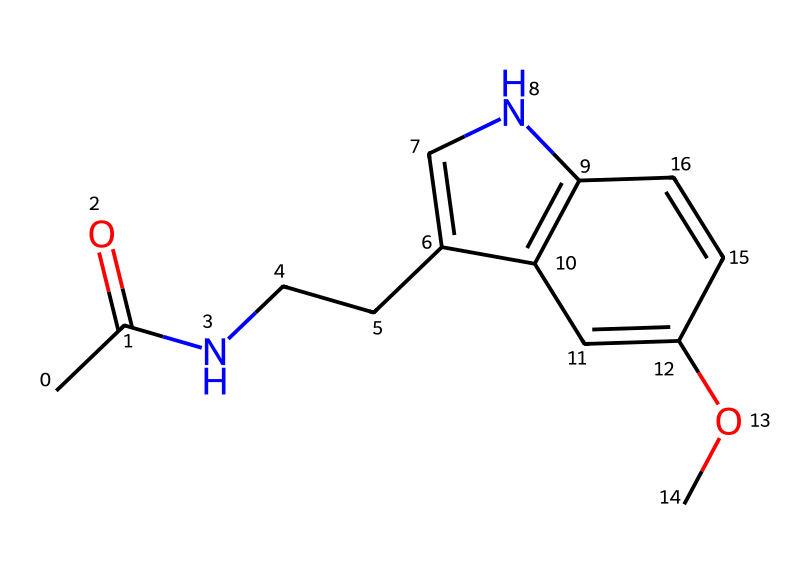What is the molecular formula of this chemical? To determine the molecular formula, we count the number of each type of atom present in the SMILES representation. The molecule contains 11 carbon (C) atoms, 13 hydrogen (H) atoms, 1 nitrogen (N) atom, and 1 oxygen (O) atom. Therefore, the molecular formula is C13H16N2O.
Answer: C13H16N2O How many rings are present in this structure? By examining the SMILES representation, we can identify two ring closures indicated by the numbers '1' and '2'. Therefore, there are two interconnected rings in the structure.
Answer: 2 What specific class of compounds does this chemical belong to? The presence of an indole-like structure (the bicyclic system) is characteristic of tryptamines, indicating that this compound is part of the tryptamine class of compounds.
Answer: tryptamine What functional groups are identified in this chemical? A functional group analysis shows that this molecule contains an acetyl group (indicated by the "CC(=O)" part) and an ether group (as shown by "C(OC)"). These groups are characteristic of its function.
Answer: acetyl and ether How many chiral centers does this molecule have? The presence of chiral centers in the molecule can be analyzed based on carbon atoms that have four different substituents. There are two such carbon atoms in this structure, indicating two chiral centers.
Answer: 2 What impact does the nitrogen atom have on the molecule's activity? The nitrogen atom in this structure contributes to the molecule's ability to interact with biological receptors, specifically influencing its activity as a sleep aid, as it is involved in binding to melatonin receptors.
Answer: receptor interaction 